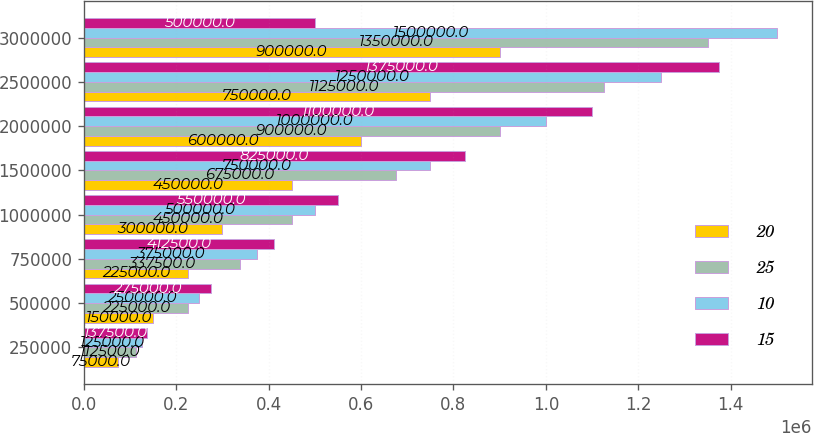Convert chart to OTSL. <chart><loc_0><loc_0><loc_500><loc_500><stacked_bar_chart><ecel><fcel>250000<fcel>500000<fcel>750000<fcel>1000000<fcel>1500000<fcel>2000000<fcel>2500000<fcel>3000000<nl><fcel>20<fcel>75000<fcel>150000<fcel>225000<fcel>300000<fcel>450000<fcel>600000<fcel>750000<fcel>900000<nl><fcel>25<fcel>112500<fcel>225000<fcel>337500<fcel>450000<fcel>675000<fcel>900000<fcel>1.125e+06<fcel>1.35e+06<nl><fcel>10<fcel>125000<fcel>250000<fcel>375000<fcel>500000<fcel>750000<fcel>1e+06<fcel>1.25e+06<fcel>1.5e+06<nl><fcel>15<fcel>137500<fcel>275000<fcel>412500<fcel>550000<fcel>825000<fcel>1.1e+06<fcel>1.375e+06<fcel>500000<nl></chart> 